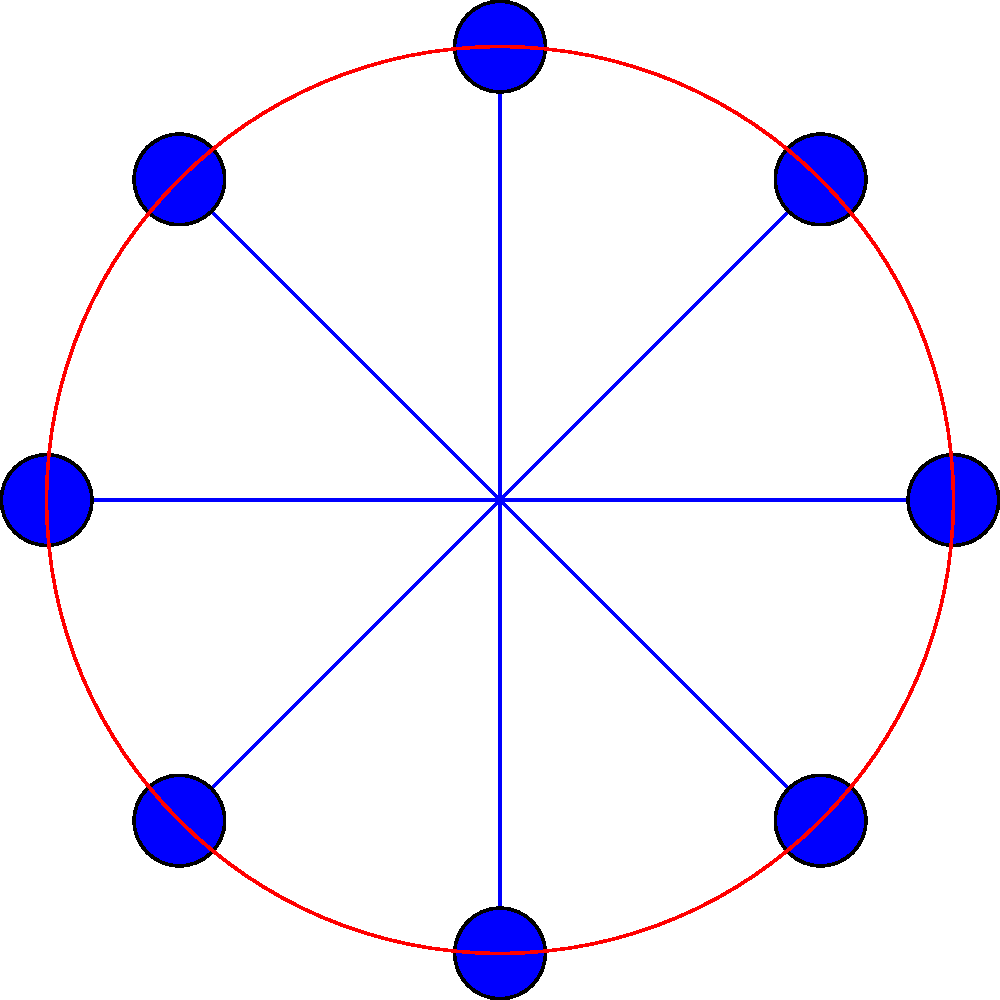In creating a mandala design inspired by Tibetan culture, you've drawn a circular pattern with 8 equally spaced points on its circumference. If you rotate this design by 45°, how many of these points will coincide with their original positions? To solve this problem, let's follow these steps:

1) First, we need to understand what a 45° rotation means in this context:
   - There are 360° in a full circle
   - The design has 8 equally spaced points
   - The angle between each point is 360° / 8 = 45°

2) When we rotate by 45°, each point will move to the position of the next point.

3) To determine how many points coincide with their original positions, we need to find points that, when moved 45°, end up in the same place.

4) In this case, there are two such points:
   - The top point (12 o'clock position) will rotate to the position of the right point (3 o'clock)
   - The bottom point (6 o'clock position) will rotate to the position of the left point (9 o'clock)

5) These two points (top and bottom) will coincide with their original positions after a 180° rotation, which is equivalent to four 45° rotations.

Therefore, 2 points will coincide with their original positions after a 45° rotation.
Answer: 2 points 